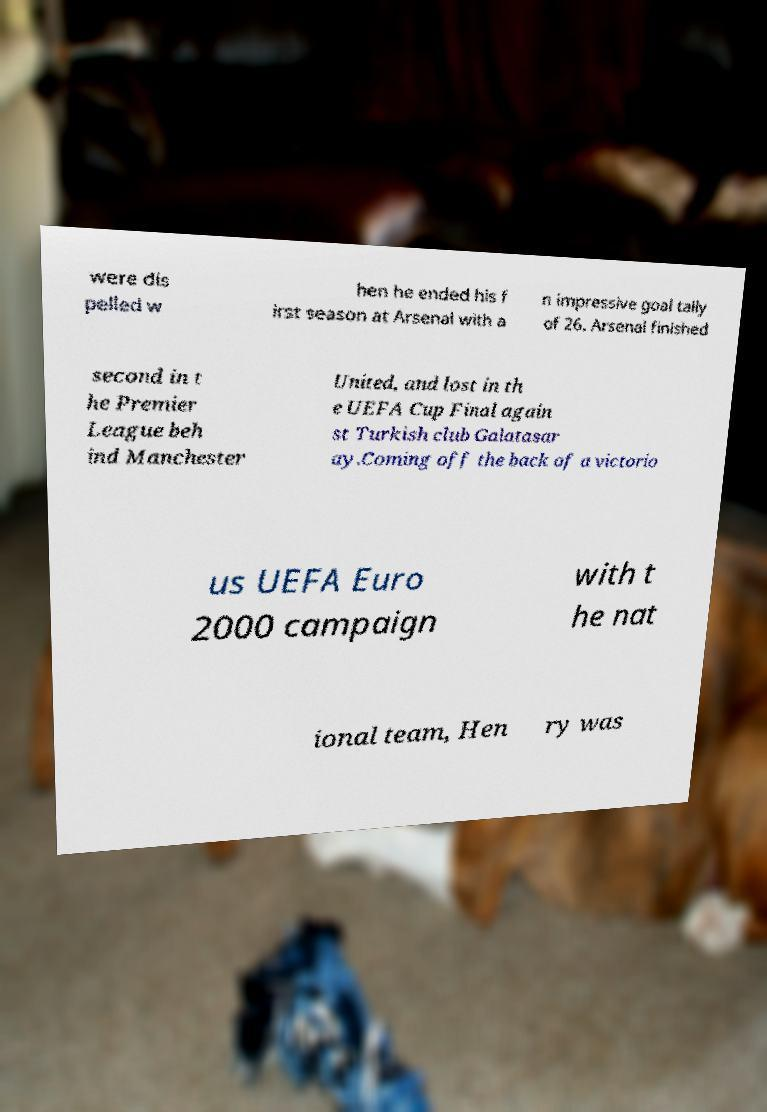Can you read and provide the text displayed in the image?This photo seems to have some interesting text. Can you extract and type it out for me? were dis pelled w hen he ended his f irst season at Arsenal with a n impressive goal tally of 26. Arsenal finished second in t he Premier League beh ind Manchester United, and lost in th e UEFA Cup Final again st Turkish club Galatasar ay.Coming off the back of a victorio us UEFA Euro 2000 campaign with t he nat ional team, Hen ry was 